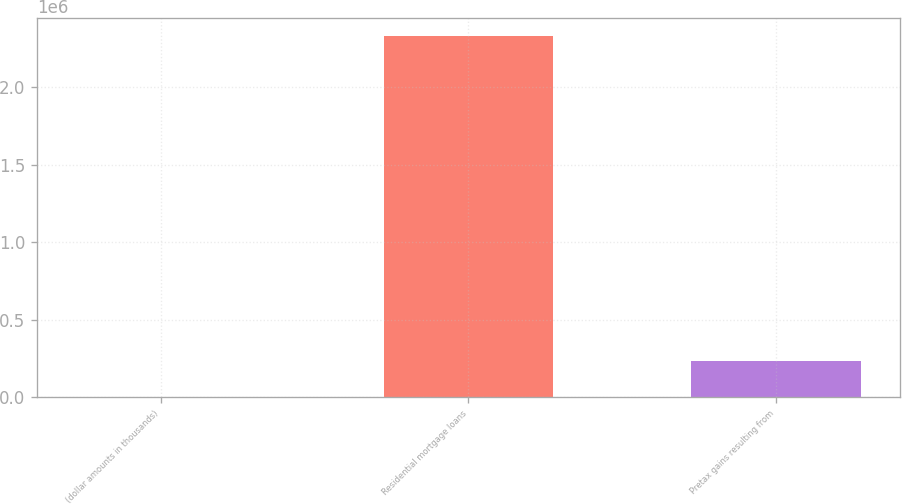<chart> <loc_0><loc_0><loc_500><loc_500><bar_chart><fcel>(dollar amounts in thousands)<fcel>Residential mortgage loans<fcel>Pretax gains resulting from<nl><fcel>2014<fcel>2.33006e+06<fcel>234819<nl></chart> 